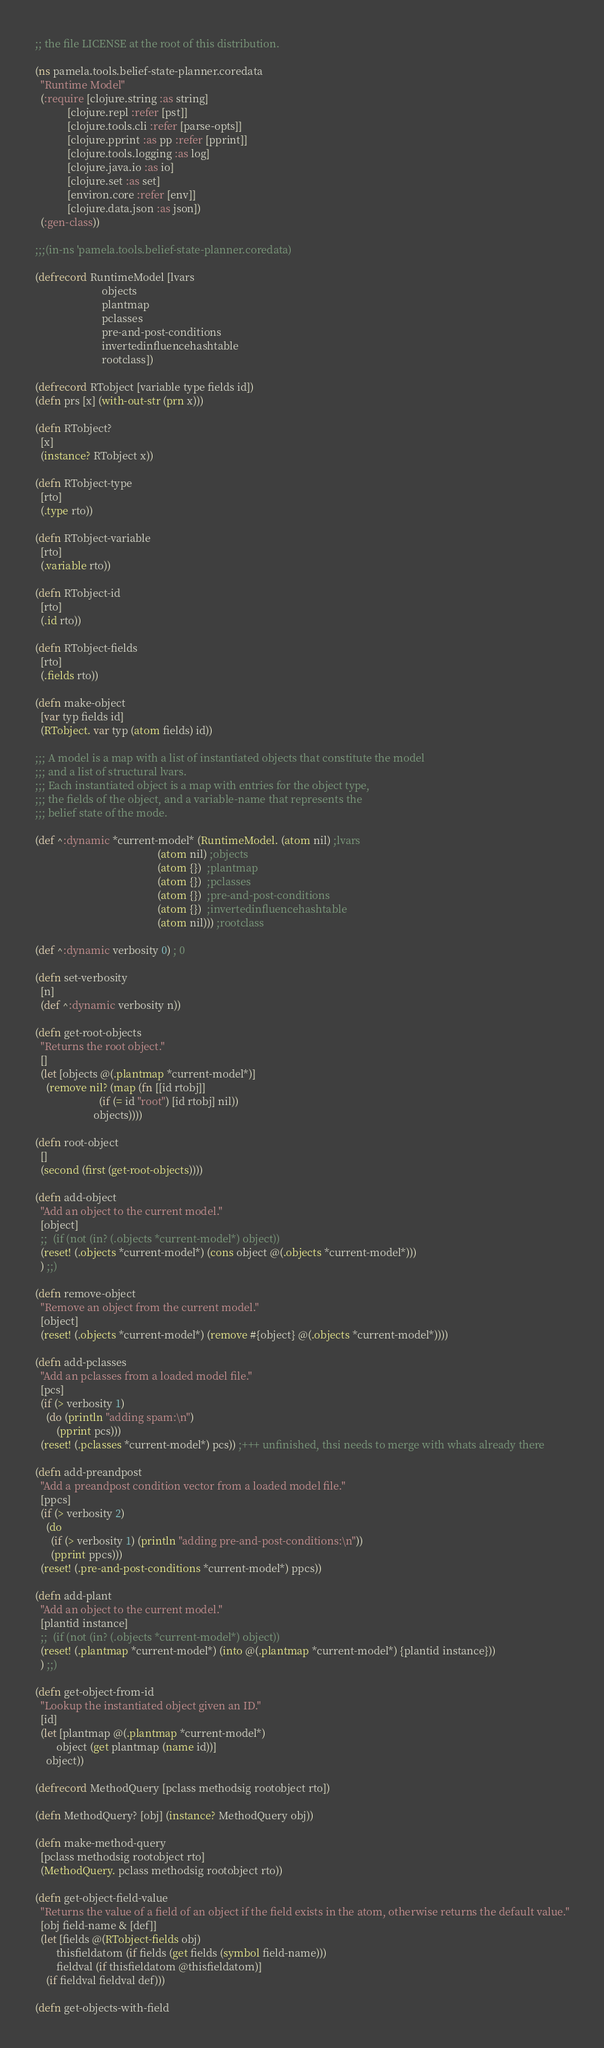Convert code to text. <code><loc_0><loc_0><loc_500><loc_500><_Clojure_>;; the file LICENSE at the root of this distribution.

(ns pamela.tools.belief-state-planner.coredata
  "Runtime Model"
  (:require [clojure.string :as string]
            [clojure.repl :refer [pst]]
            [clojure.tools.cli :refer [parse-opts]]
            [clojure.pprint :as pp :refer [pprint]]
            [clojure.tools.logging :as log]
            [clojure.java.io :as io]
            [clojure.set :as set]
            [environ.core :refer [env]]
            [clojure.data.json :as json])
  (:gen-class))

;;;(in-ns 'pamela.tools.belief-state-planner.coredata)

(defrecord RuntimeModel [lvars
                         objects
                         plantmap
                         pclasses
                         pre-and-post-conditions
                         invertedinfluencehashtable
                         rootclass])

(defrecord RTobject [variable type fields id])
(defn prs [x] (with-out-str (prn x)))

(defn RTobject?
  [x]
  (instance? RTobject x))

(defn RTobject-type
  [rto]
  (.type rto))

(defn RTobject-variable
  [rto]
  (.variable rto))

(defn RTobject-id
  [rto]
  (.id rto))

(defn RTobject-fields
  [rto]
  (.fields rto))

(defn make-object
  [var typ fields id]
  (RTobject. var typ (atom fields) id))

;;; A model is a map with a list of instantiated objects that constitute the model
;;; and a list of structural lvars.
;;; Each instantiated object is a map with entries for the object type,
;;; the fields of the object, and a variable-name that represents the
;;; belief state of the mode.

(def ^:dynamic *current-model* (RuntimeModel. (atom nil) ;lvars
                                              (atom nil) ;objects
                                              (atom {})  ;plantmap
                                              (atom {})  ;pclasses
                                              (atom {})  ;pre-and-post-conditions
                                              (atom {})  ;invertedinfluencehashtable
                                              (atom nil))) ;rootclass

(def ^:dynamic verbosity 0) ; 0

(defn set-verbosity
  [n]
  (def ^:dynamic verbosity n))

(defn get-root-objects
  "Returns the root object."
  []
  (let [objects @(.plantmap *current-model*)]
    (remove nil? (map (fn [[id rtobj]]
                        (if (= id "root") [id rtobj] nil))
                      objects))))

(defn root-object
  []
  (second (first (get-root-objects))))

(defn add-object
  "Add an object to the current model."
  [object]
  ;;  (if (not (in? (.objects *current-model*) object))
  (reset! (.objects *current-model*) (cons object @(.objects *current-model*)))
  ) ;;)

(defn remove-object
  "Remove an object from the current model."
  [object]
  (reset! (.objects *current-model*) (remove #{object} @(.objects *current-model*))))

(defn add-pclasses
  "Add an pclasses from a loaded model file."
  [pcs]
  (if (> verbosity 1)
    (do (println "adding spam:\n")
        (pprint pcs)))
  (reset! (.pclasses *current-model*) pcs)) ;+++ unfinished, thsi needs to merge with whats already there

(defn add-preandpost
  "Add a preandpost condition vector from a loaded model file."
  [ppcs]
  (if (> verbosity 2)
    (do
      (if (> verbosity 1) (println "adding pre-and-post-conditions:\n"))
      (pprint ppcs)))
  (reset! (.pre-and-post-conditions *current-model*) ppcs))

(defn add-plant
  "Add an object to the current model."
  [plantid instance]
  ;;  (if (not (in? (.objects *current-model*) object))
  (reset! (.plantmap *current-model*) (into @(.plantmap *current-model*) {plantid instance}))
  ) ;;)

(defn get-object-from-id
  "Lookup the instantiated object given an ID."
  [id]
  (let [plantmap @(.plantmap *current-model*)
        object (get plantmap (name id))]
    object))

(defrecord MethodQuery [pclass methodsig rootobject rto])

(defn MethodQuery? [obj] (instance? MethodQuery obj))

(defn make-method-query
  [pclass methodsig rootobject rto]
  (MethodQuery. pclass methodsig rootobject rto))

(defn get-object-field-value
  "Returns the value of a field of an object if the field exists in the atom, otherwise returns the default value."
  [obj field-name & [def]]
  (let [fields @(RTobject-fields obj)
        thisfieldatom (if fields (get fields (symbol field-name)))
        fieldval (if thisfieldatom @thisfieldatom)]
    (if fieldval fieldval def)))

(defn get-objects-with-field</code> 